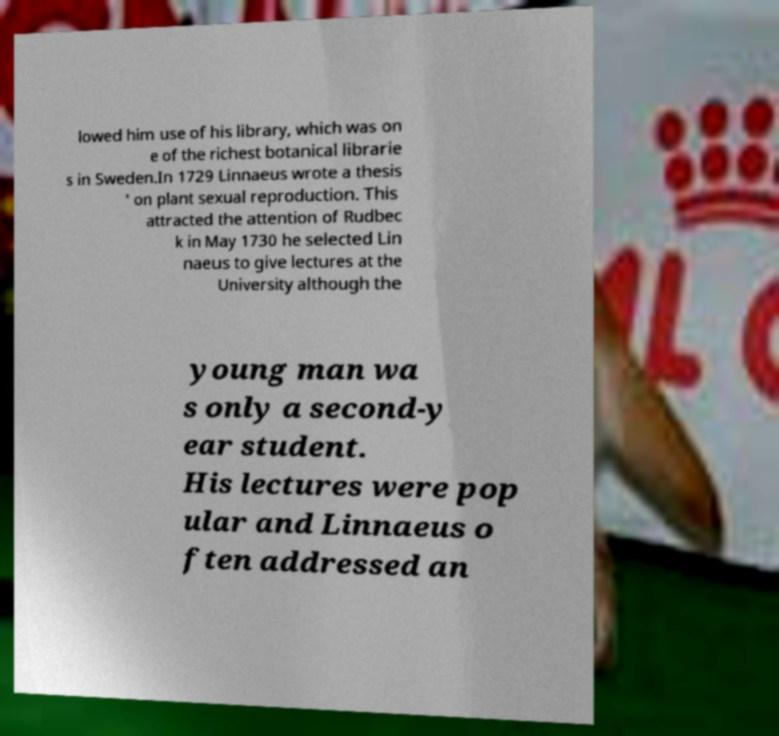Can you accurately transcribe the text from the provided image for me? lowed him use of his library, which was on e of the richest botanical librarie s in Sweden.In 1729 Linnaeus wrote a thesis ' on plant sexual reproduction. This attracted the attention of Rudbec k in May 1730 he selected Lin naeus to give lectures at the University although the young man wa s only a second-y ear student. His lectures were pop ular and Linnaeus o ften addressed an 